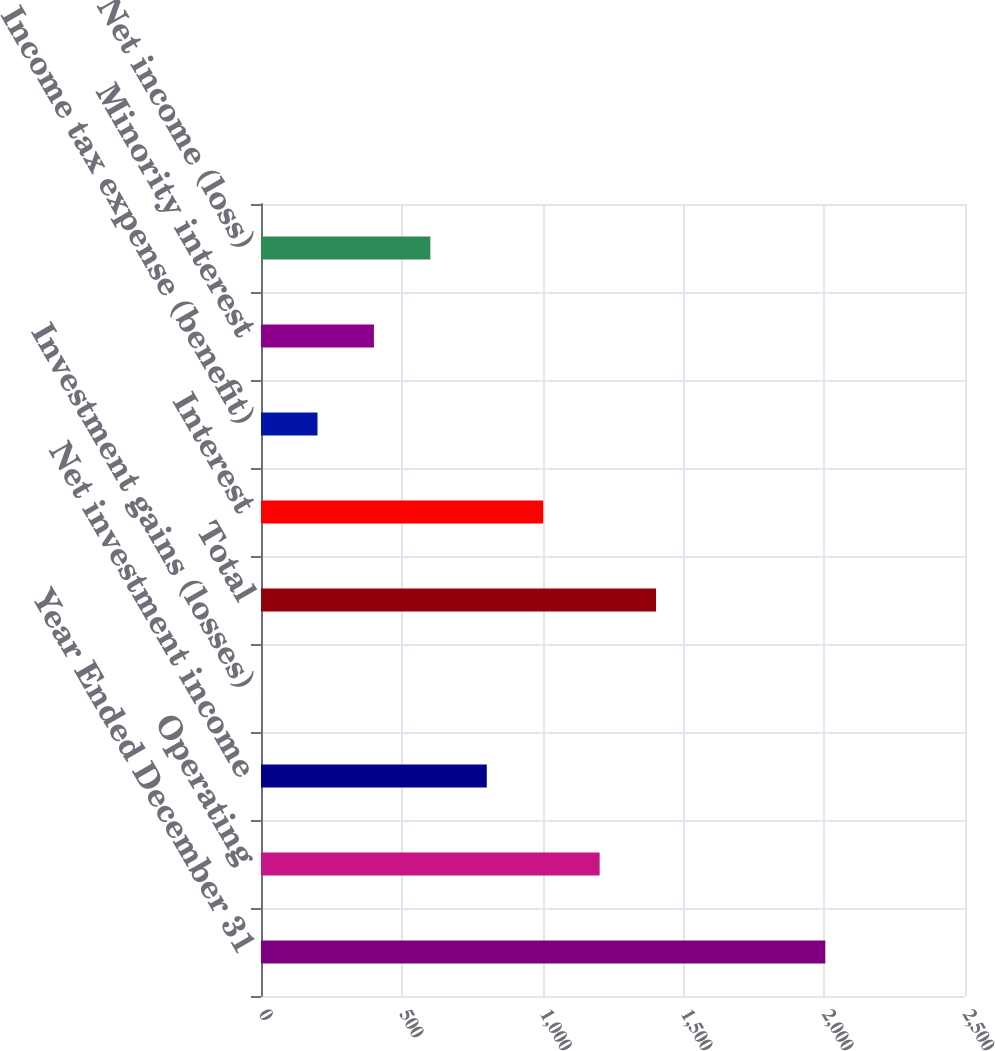Convert chart. <chart><loc_0><loc_0><loc_500><loc_500><bar_chart><fcel>Year Ended December 31<fcel>Operating<fcel>Net investment income<fcel>Investment gains (losses)<fcel>Total<fcel>Interest<fcel>Income tax expense (benefit)<fcel>Minority interest<fcel>Net income (loss)<nl><fcel>2004<fcel>1202.52<fcel>801.78<fcel>0.3<fcel>1402.89<fcel>1002.15<fcel>200.67<fcel>401.04<fcel>601.41<nl></chart> 